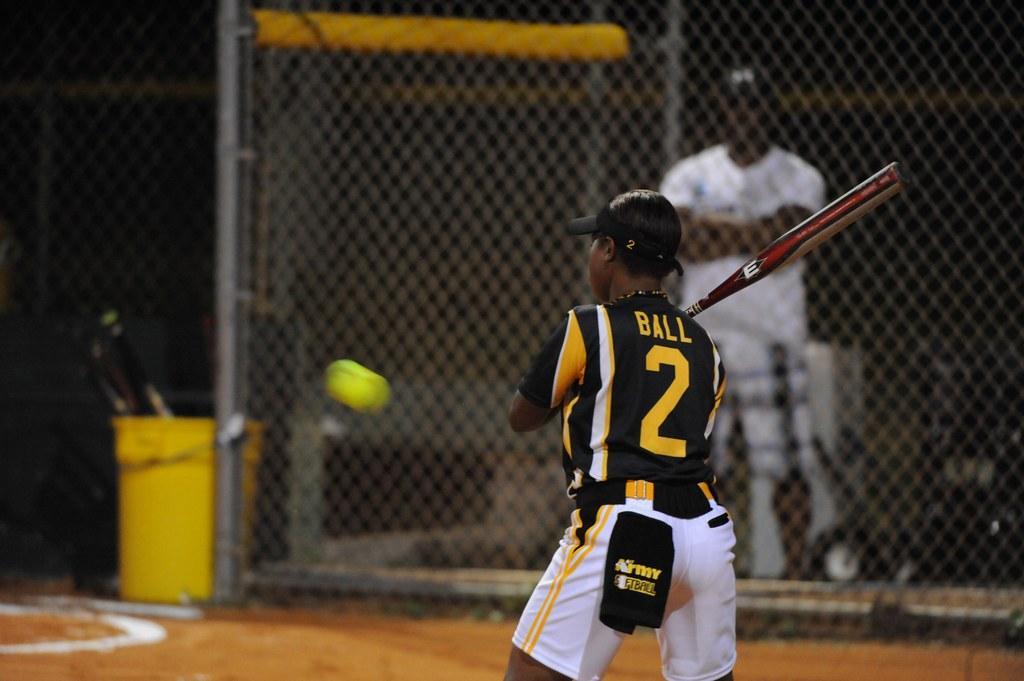<image>
Give a short and clear explanation of the subsequent image. player number 2 holds the bat and gets ready to take a swing 